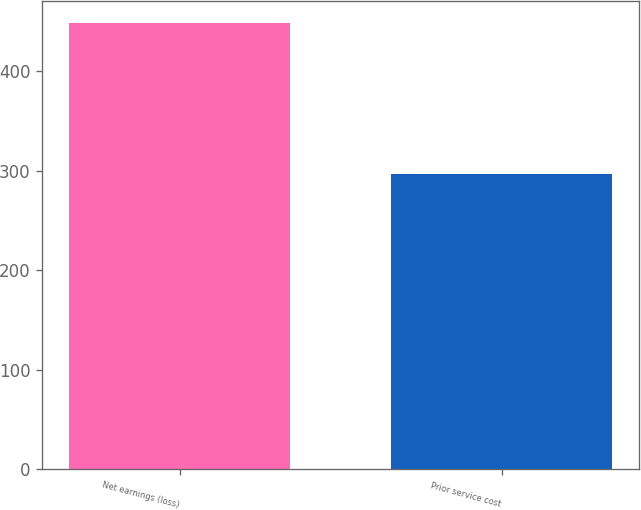Convert chart. <chart><loc_0><loc_0><loc_500><loc_500><bar_chart><fcel>Net earnings (loss)<fcel>Prior service cost<nl><fcel>448<fcel>297<nl></chart> 